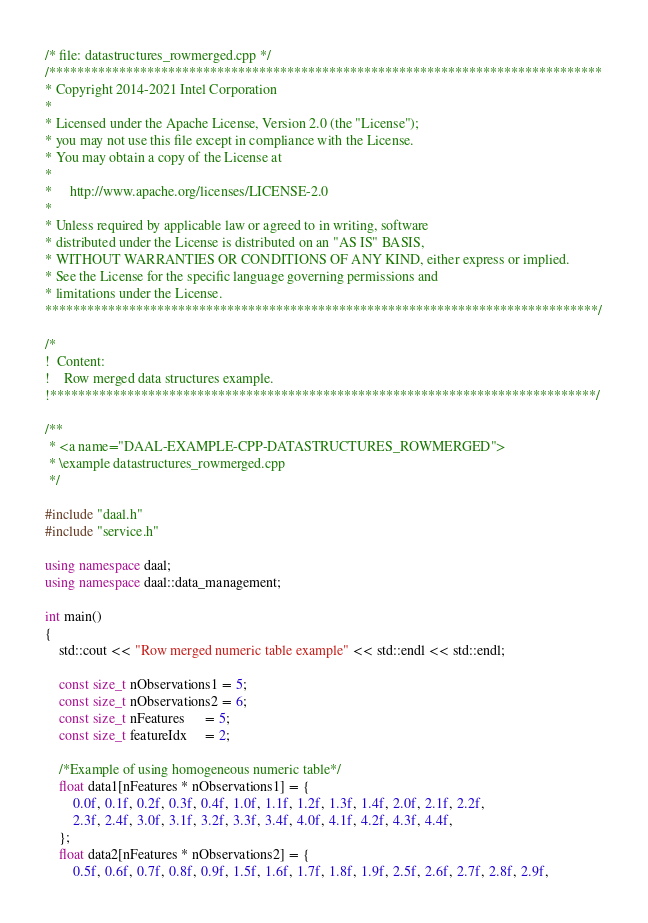<code> <loc_0><loc_0><loc_500><loc_500><_C++_>/* file: datastructures_rowmerged.cpp */
/*******************************************************************************
* Copyright 2014-2021 Intel Corporation
*
* Licensed under the Apache License, Version 2.0 (the "License");
* you may not use this file except in compliance with the License.
* You may obtain a copy of the License at
*
*     http://www.apache.org/licenses/LICENSE-2.0
*
* Unless required by applicable law or agreed to in writing, software
* distributed under the License is distributed on an "AS IS" BASIS,
* WITHOUT WARRANTIES OR CONDITIONS OF ANY KIND, either express or implied.
* See the License for the specific language governing permissions and
* limitations under the License.
*******************************************************************************/

/*
!  Content:
!    Row merged data structures example.
!******************************************************************************/

/**
 * <a name="DAAL-EXAMPLE-CPP-DATASTRUCTURES_ROWMERGED">
 * \example datastructures_rowmerged.cpp
 */

#include "daal.h"
#include "service.h"

using namespace daal;
using namespace daal::data_management;

int main()
{
    std::cout << "Row merged numeric table example" << std::endl << std::endl;

    const size_t nObservations1 = 5;
    const size_t nObservations2 = 6;
    const size_t nFeatures      = 5;
    const size_t featureIdx     = 2;

    /*Example of using homogeneous numeric table*/
    float data1[nFeatures * nObservations1] = {
        0.0f, 0.1f, 0.2f, 0.3f, 0.4f, 1.0f, 1.1f, 1.2f, 1.3f, 1.4f, 2.0f, 2.1f, 2.2f,
        2.3f, 2.4f, 3.0f, 3.1f, 3.2f, 3.3f, 3.4f, 4.0f, 4.1f, 4.2f, 4.3f, 4.4f,
    };
    float data2[nFeatures * nObservations2] = {
        0.5f, 0.6f, 0.7f, 0.8f, 0.9f, 1.5f, 1.6f, 1.7f, 1.8f, 1.9f, 2.5f, 2.6f, 2.7f, 2.8f, 2.9f,</code> 